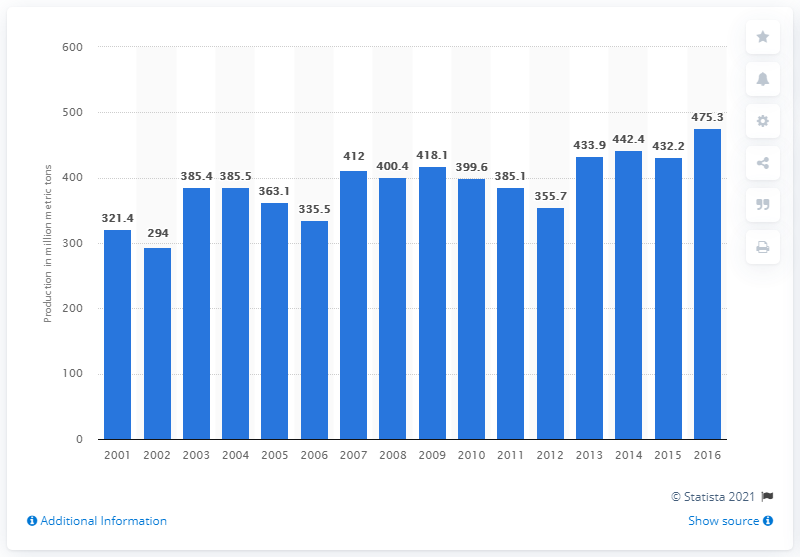Mention a couple of crucial points in this snapshot. In 2014, the total production of grain in the United States was 442.4 million metric tons. 